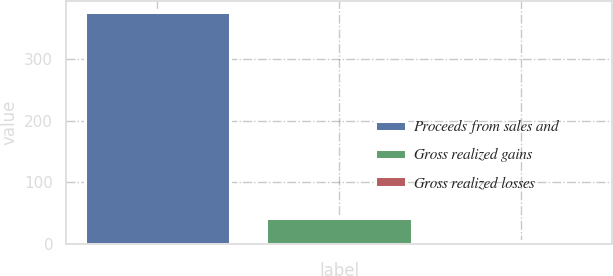<chart> <loc_0><loc_0><loc_500><loc_500><bar_chart><fcel>Proceeds from sales and<fcel>Gross realized gains<fcel>Gross realized losses<nl><fcel>377<fcel>41.3<fcel>4<nl></chart> 